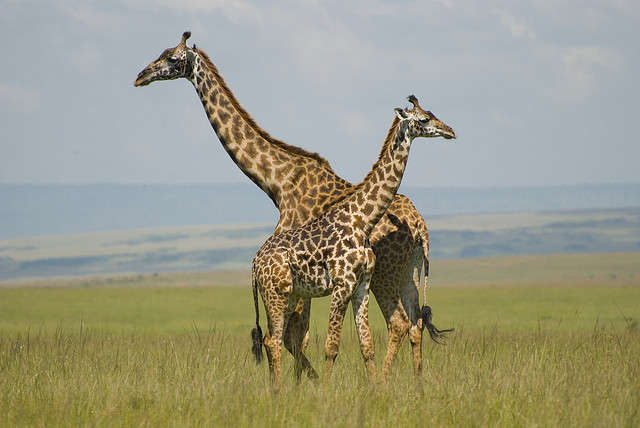<image>How tall is the grass the giraffes are standing in? It is ambiguous to determine the height of the grass the giraffes are standing in. It can be anywhere from knee height to three feet. How tall is the grass the giraffes are standing in? It is unanswerable how tall the grass the giraffes are standing in. 